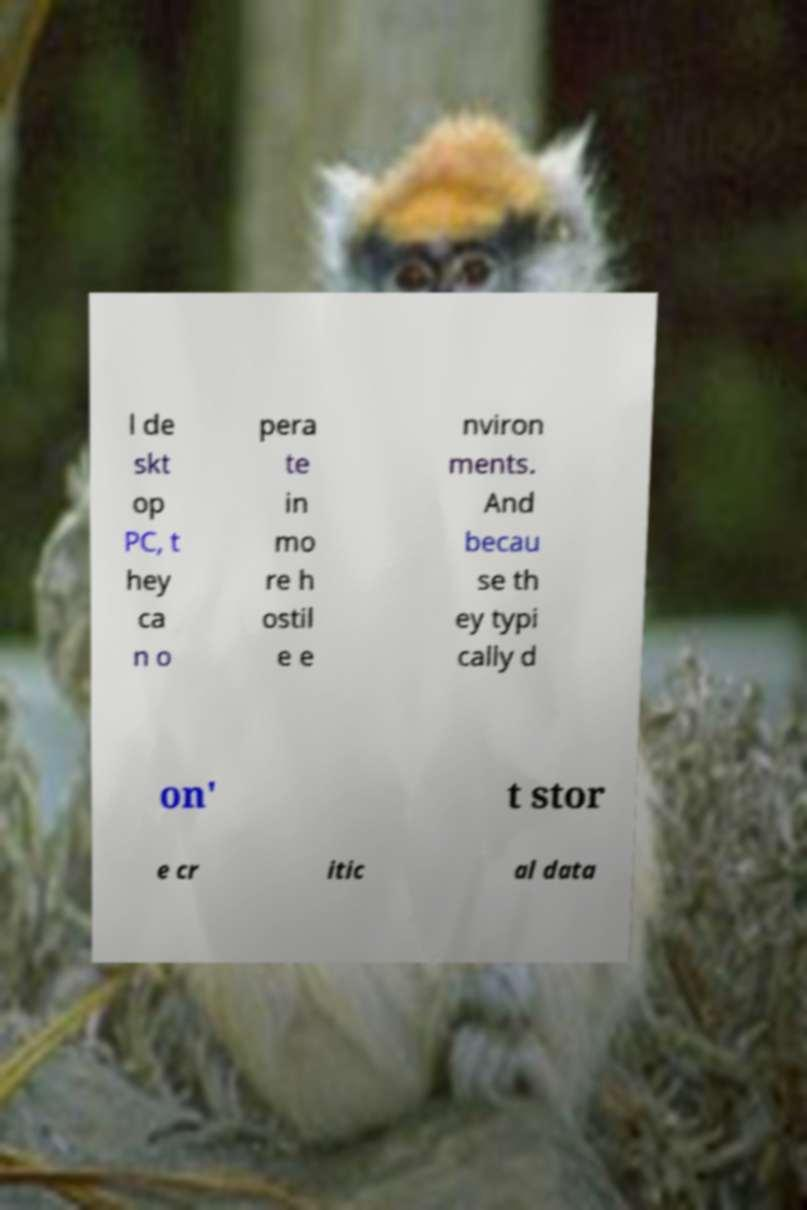There's text embedded in this image that I need extracted. Can you transcribe it verbatim? l de skt op PC, t hey ca n o pera te in mo re h ostil e e nviron ments. And becau se th ey typi cally d on' t stor e cr itic al data 